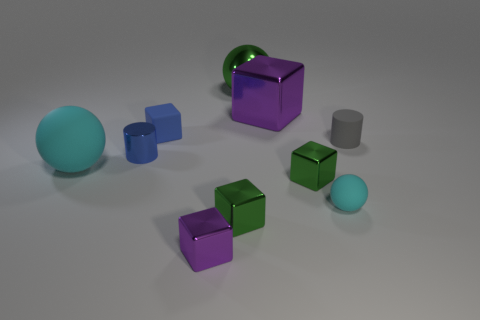Subtract all blue blocks. How many blocks are left? 4 Subtract all tiny matte blocks. How many blocks are left? 4 Subtract all brown blocks. Subtract all cyan spheres. How many blocks are left? 5 Subtract all cylinders. How many objects are left? 8 Add 2 large red rubber cylinders. How many large red rubber cylinders exist? 2 Subtract 0 brown cubes. How many objects are left? 10 Subtract all small blue matte things. Subtract all metal blocks. How many objects are left? 5 Add 4 metal blocks. How many metal blocks are left? 8 